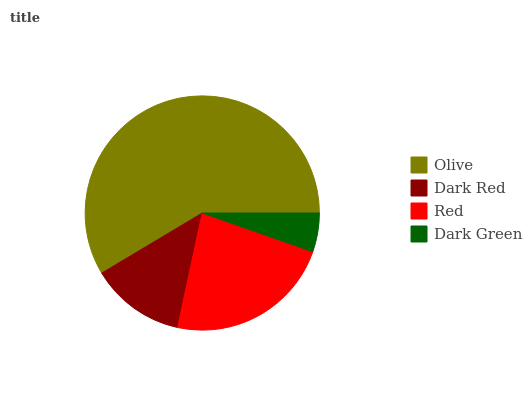Is Dark Green the minimum?
Answer yes or no. Yes. Is Olive the maximum?
Answer yes or no. Yes. Is Dark Red the minimum?
Answer yes or no. No. Is Dark Red the maximum?
Answer yes or no. No. Is Olive greater than Dark Red?
Answer yes or no. Yes. Is Dark Red less than Olive?
Answer yes or no. Yes. Is Dark Red greater than Olive?
Answer yes or no. No. Is Olive less than Dark Red?
Answer yes or no. No. Is Red the high median?
Answer yes or no. Yes. Is Dark Red the low median?
Answer yes or no. Yes. Is Dark Green the high median?
Answer yes or no. No. Is Red the low median?
Answer yes or no. No. 